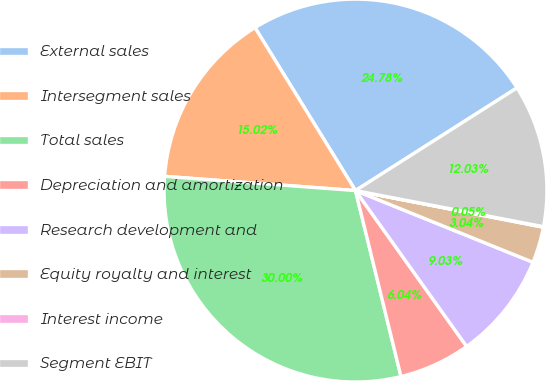Convert chart. <chart><loc_0><loc_0><loc_500><loc_500><pie_chart><fcel>External sales<fcel>Intersegment sales<fcel>Total sales<fcel>Depreciation and amortization<fcel>Research development and<fcel>Equity royalty and interest<fcel>Interest income<fcel>Segment EBIT<nl><fcel>24.78%<fcel>15.02%<fcel>30.0%<fcel>6.04%<fcel>9.03%<fcel>3.04%<fcel>0.05%<fcel>12.03%<nl></chart> 